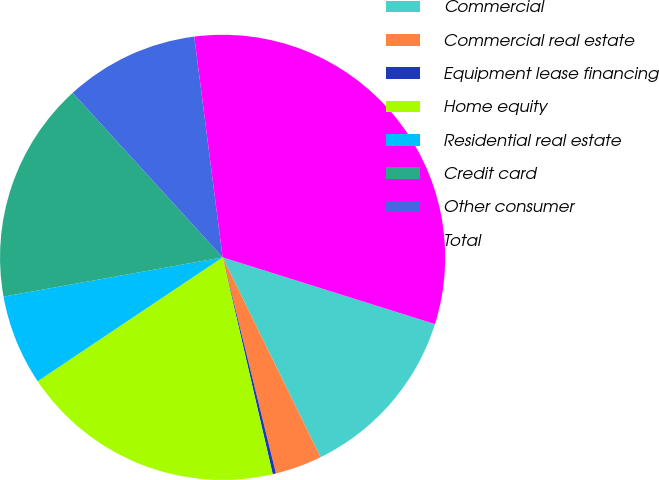Convert chart to OTSL. <chart><loc_0><loc_0><loc_500><loc_500><pie_chart><fcel>Commercial<fcel>Commercial real estate<fcel>Equipment lease financing<fcel>Home equity<fcel>Residential real estate<fcel>Credit card<fcel>Other consumer<fcel>Total<nl><fcel>12.9%<fcel>3.4%<fcel>0.24%<fcel>19.22%<fcel>6.57%<fcel>16.06%<fcel>9.73%<fcel>31.88%<nl></chart> 